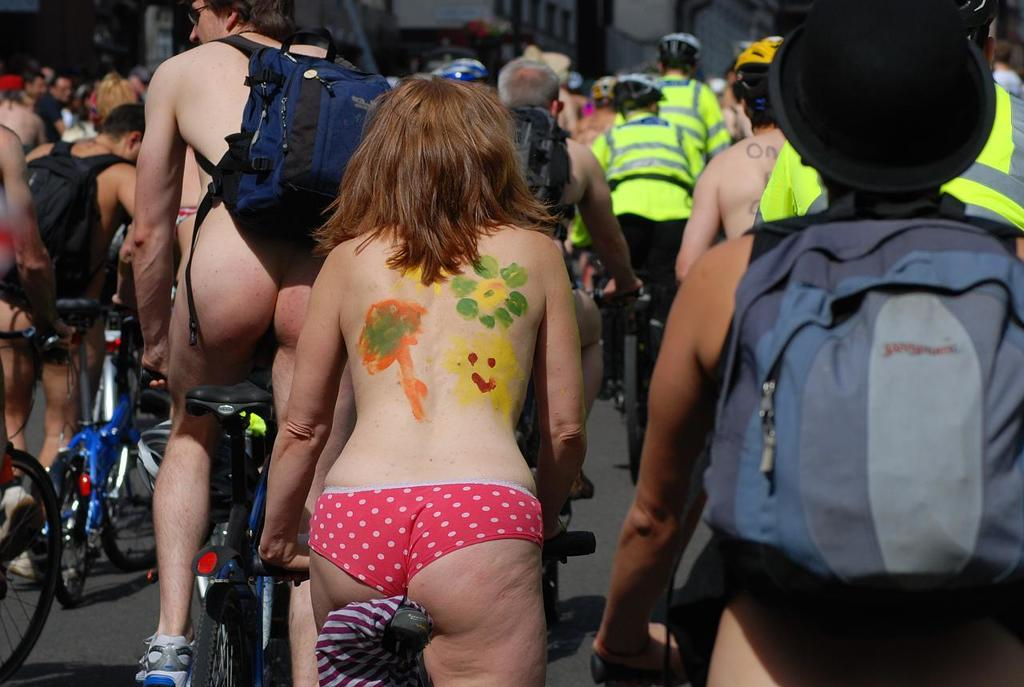What are the people in the image doing? The people in the image are riding bicycles. What are the people wearing while riding bicycles? The people are wearing uniforms and helmets. Can you describe any additional items the people are carrying or wearing? A man is carrying a backpack, and a woman has a water paint on her body. What type of expert can be seen giving a lecture in the image? There is no expert giving a lecture in the image; it features a group of people riding bicycles. Can you tell me how many tails are visible on the bicycles in the image? There are no tails visible on the bicycles in the image. 